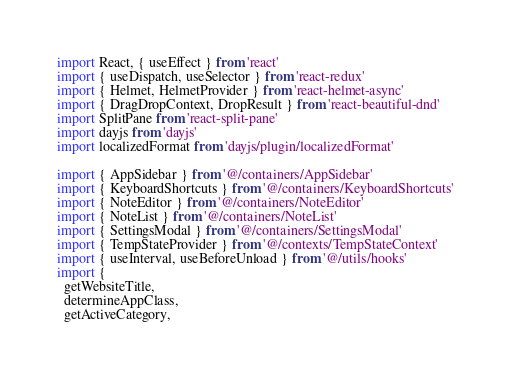<code> <loc_0><loc_0><loc_500><loc_500><_TypeScript_>import React, { useEffect } from 'react'
import { useDispatch, useSelector } from 'react-redux'
import { Helmet, HelmetProvider } from 'react-helmet-async'
import { DragDropContext, DropResult } from 'react-beautiful-dnd'
import SplitPane from 'react-split-pane'
import dayjs from 'dayjs'
import localizedFormat from 'dayjs/plugin/localizedFormat'

import { AppSidebar } from '@/containers/AppSidebar'
import { KeyboardShortcuts } from '@/containers/KeyboardShortcuts'
import { NoteEditor } from '@/containers/NoteEditor'
import { NoteList } from '@/containers/NoteList'
import { SettingsModal } from '@/containers/SettingsModal'
import { TempStateProvider } from '@/contexts/TempStateContext'
import { useInterval, useBeforeUnload } from '@/utils/hooks'
import {
  getWebsiteTitle,
  determineAppClass,
  getActiveCategory,</code> 